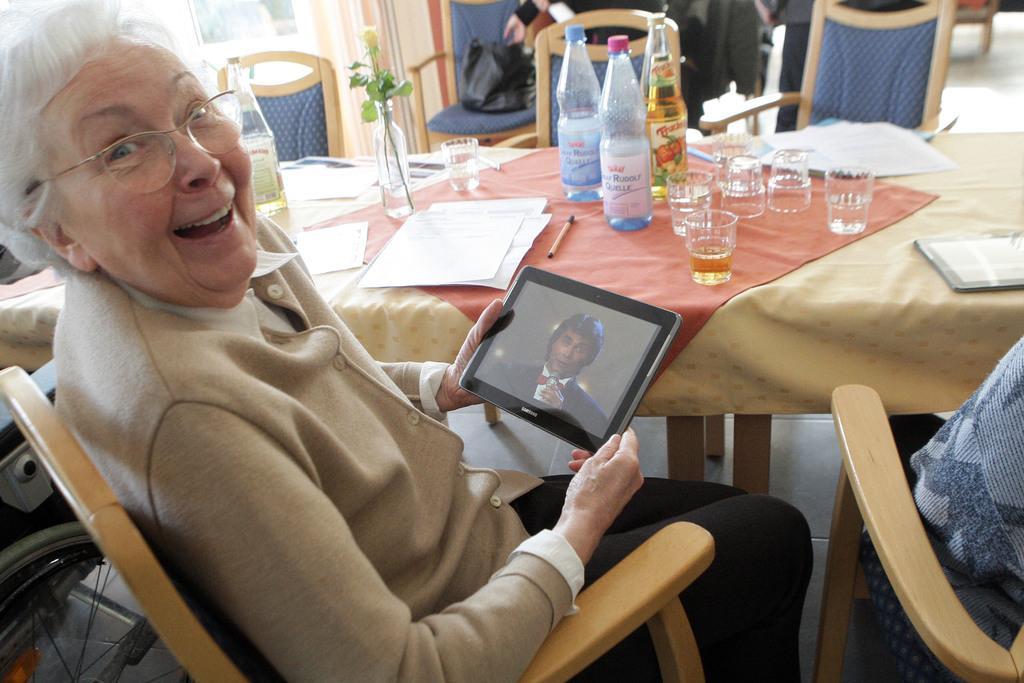In one or two sentences, can you explain what this image depicts? In this image their is a woman who is sitting in a chair and looking at the tab with her hands and their is a table in front of her on which there are glasses,bottles,papers,pen and a flower vase. There is a bag on the chair. 